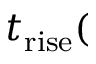<formula> <loc_0><loc_0><loc_500><loc_500>t _ { r i s e } (</formula> 